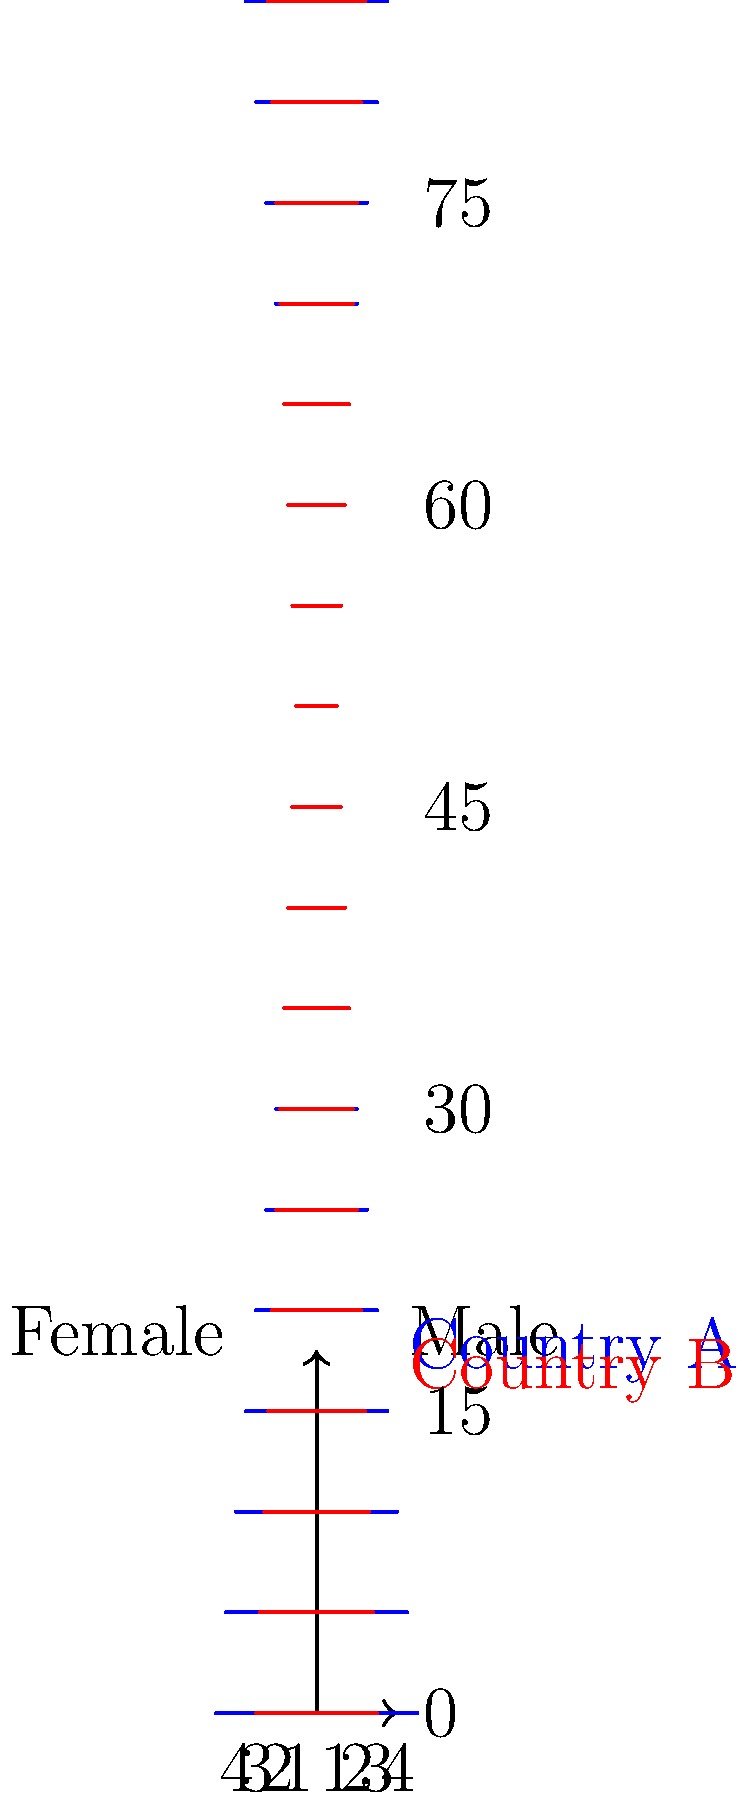Analyze the population pyramid chart comparing healthcare demographics in two countries. Which country is likely to have a higher demand for geriatric care services, and why? To determine which country is likely to have a higher demand for geriatric care services, we need to analyze the older age groups in both countries:

1. Observe the upper portions of the pyramid (ages 65 and above):
   - Country A (blue) shows wider bars for these age groups
   - Country B (red) shows narrower bars for these age groups

2. Compare the proportions:
   - Country A has a larger percentage of its population in the 65+ age groups
   - Country B has a smaller percentage of its population in the 65+ age groups

3. Consider the implications:
   - A larger older population typically requires more geriatric care services
   - Geriatric care includes specialized medical treatment, long-term care facilities, and home health services

4. Analyze the overall shape:
   - Country A's pyramid is more top-heavy, indicating an aging population
   - Country B's pyramid is more evenly distributed, suggesting a younger overall population

5. Consider healthcare system implications:
   - Country A will likely need to allocate more resources to geriatric care
   - Country B may need to focus on a broader range of healthcare services for various age groups

Given these observations, Country A is more likely to have a higher demand for geriatric care services due to its larger proportion of older adults in the population.
Answer: Country A, due to its larger proportion of older adults. 